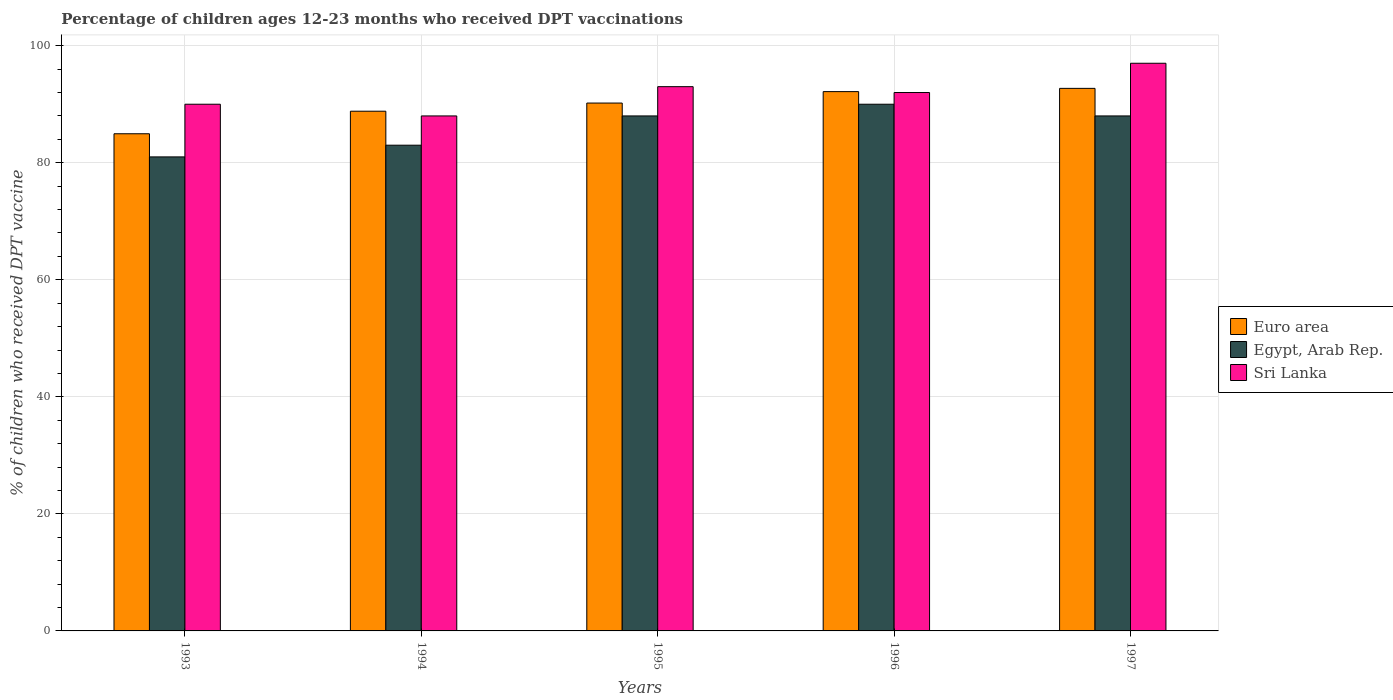Are the number of bars per tick equal to the number of legend labels?
Your answer should be very brief. Yes. How many bars are there on the 1st tick from the right?
Offer a very short reply. 3. In how many cases, is the number of bars for a given year not equal to the number of legend labels?
Offer a terse response. 0. What is the percentage of children who received DPT vaccination in Sri Lanka in 1995?
Keep it short and to the point. 93. Across all years, what is the maximum percentage of children who received DPT vaccination in Egypt, Arab Rep.?
Keep it short and to the point. 90. Across all years, what is the minimum percentage of children who received DPT vaccination in Sri Lanka?
Ensure brevity in your answer.  88. In which year was the percentage of children who received DPT vaccination in Euro area maximum?
Keep it short and to the point. 1997. What is the total percentage of children who received DPT vaccination in Euro area in the graph?
Give a very brief answer. 448.82. What is the difference between the percentage of children who received DPT vaccination in Sri Lanka in 1994 and that in 1996?
Keep it short and to the point. -4. What is the difference between the percentage of children who received DPT vaccination in Sri Lanka in 1996 and the percentage of children who received DPT vaccination in Euro area in 1994?
Ensure brevity in your answer.  3.19. What is the average percentage of children who received DPT vaccination in Egypt, Arab Rep. per year?
Give a very brief answer. 86. In the year 1993, what is the difference between the percentage of children who received DPT vaccination in Euro area and percentage of children who received DPT vaccination in Egypt, Arab Rep.?
Provide a short and direct response. 3.95. What is the ratio of the percentage of children who received DPT vaccination in Egypt, Arab Rep. in 1994 to that in 1997?
Your answer should be very brief. 0.94. What is the difference between the highest and the lowest percentage of children who received DPT vaccination in Sri Lanka?
Your response must be concise. 9. What does the 2nd bar from the left in 1993 represents?
Your answer should be compact. Egypt, Arab Rep. What does the 2nd bar from the right in 1993 represents?
Your response must be concise. Egypt, Arab Rep. Are all the bars in the graph horizontal?
Keep it short and to the point. No. Are the values on the major ticks of Y-axis written in scientific E-notation?
Provide a succinct answer. No. Does the graph contain any zero values?
Ensure brevity in your answer.  No. Does the graph contain grids?
Give a very brief answer. Yes. Where does the legend appear in the graph?
Provide a succinct answer. Center right. How are the legend labels stacked?
Offer a very short reply. Vertical. What is the title of the graph?
Keep it short and to the point. Percentage of children ages 12-23 months who received DPT vaccinations. What is the label or title of the Y-axis?
Offer a very short reply. % of children who received DPT vaccine. What is the % of children who received DPT vaccine in Euro area in 1993?
Your response must be concise. 84.95. What is the % of children who received DPT vaccine in Euro area in 1994?
Your answer should be compact. 88.81. What is the % of children who received DPT vaccine in Euro area in 1995?
Make the answer very short. 90.2. What is the % of children who received DPT vaccine in Egypt, Arab Rep. in 1995?
Give a very brief answer. 88. What is the % of children who received DPT vaccine of Sri Lanka in 1995?
Offer a terse response. 93. What is the % of children who received DPT vaccine in Euro area in 1996?
Your answer should be compact. 92.15. What is the % of children who received DPT vaccine of Sri Lanka in 1996?
Provide a short and direct response. 92. What is the % of children who received DPT vaccine of Euro area in 1997?
Offer a very short reply. 92.71. What is the % of children who received DPT vaccine in Sri Lanka in 1997?
Give a very brief answer. 97. Across all years, what is the maximum % of children who received DPT vaccine of Euro area?
Offer a terse response. 92.71. Across all years, what is the maximum % of children who received DPT vaccine in Egypt, Arab Rep.?
Your answer should be compact. 90. Across all years, what is the maximum % of children who received DPT vaccine of Sri Lanka?
Offer a very short reply. 97. Across all years, what is the minimum % of children who received DPT vaccine of Euro area?
Your response must be concise. 84.95. Across all years, what is the minimum % of children who received DPT vaccine of Egypt, Arab Rep.?
Offer a terse response. 81. Across all years, what is the minimum % of children who received DPT vaccine in Sri Lanka?
Provide a short and direct response. 88. What is the total % of children who received DPT vaccine of Euro area in the graph?
Your answer should be very brief. 448.82. What is the total % of children who received DPT vaccine in Egypt, Arab Rep. in the graph?
Keep it short and to the point. 430. What is the total % of children who received DPT vaccine in Sri Lanka in the graph?
Provide a succinct answer. 460. What is the difference between the % of children who received DPT vaccine of Euro area in 1993 and that in 1994?
Make the answer very short. -3.85. What is the difference between the % of children who received DPT vaccine of Euro area in 1993 and that in 1995?
Give a very brief answer. -5.25. What is the difference between the % of children who received DPT vaccine of Egypt, Arab Rep. in 1993 and that in 1995?
Provide a short and direct response. -7. What is the difference between the % of children who received DPT vaccine in Euro area in 1993 and that in 1996?
Ensure brevity in your answer.  -7.2. What is the difference between the % of children who received DPT vaccine of Egypt, Arab Rep. in 1993 and that in 1996?
Offer a very short reply. -9. What is the difference between the % of children who received DPT vaccine in Sri Lanka in 1993 and that in 1996?
Offer a very short reply. -2. What is the difference between the % of children who received DPT vaccine in Euro area in 1993 and that in 1997?
Give a very brief answer. -7.76. What is the difference between the % of children who received DPT vaccine in Egypt, Arab Rep. in 1993 and that in 1997?
Provide a succinct answer. -7. What is the difference between the % of children who received DPT vaccine in Sri Lanka in 1993 and that in 1997?
Provide a short and direct response. -7. What is the difference between the % of children who received DPT vaccine of Euro area in 1994 and that in 1995?
Offer a very short reply. -1.39. What is the difference between the % of children who received DPT vaccine in Egypt, Arab Rep. in 1994 and that in 1995?
Your response must be concise. -5. What is the difference between the % of children who received DPT vaccine of Euro area in 1994 and that in 1996?
Offer a very short reply. -3.35. What is the difference between the % of children who received DPT vaccine of Euro area in 1994 and that in 1997?
Offer a terse response. -3.9. What is the difference between the % of children who received DPT vaccine in Egypt, Arab Rep. in 1994 and that in 1997?
Ensure brevity in your answer.  -5. What is the difference between the % of children who received DPT vaccine in Euro area in 1995 and that in 1996?
Your answer should be compact. -1.95. What is the difference between the % of children who received DPT vaccine of Sri Lanka in 1995 and that in 1996?
Offer a very short reply. 1. What is the difference between the % of children who received DPT vaccine in Euro area in 1995 and that in 1997?
Provide a succinct answer. -2.51. What is the difference between the % of children who received DPT vaccine in Sri Lanka in 1995 and that in 1997?
Your answer should be very brief. -4. What is the difference between the % of children who received DPT vaccine of Euro area in 1996 and that in 1997?
Give a very brief answer. -0.56. What is the difference between the % of children who received DPT vaccine in Sri Lanka in 1996 and that in 1997?
Keep it short and to the point. -5. What is the difference between the % of children who received DPT vaccine in Euro area in 1993 and the % of children who received DPT vaccine in Egypt, Arab Rep. in 1994?
Keep it short and to the point. 1.95. What is the difference between the % of children who received DPT vaccine in Euro area in 1993 and the % of children who received DPT vaccine in Sri Lanka in 1994?
Make the answer very short. -3.05. What is the difference between the % of children who received DPT vaccine in Euro area in 1993 and the % of children who received DPT vaccine in Egypt, Arab Rep. in 1995?
Make the answer very short. -3.05. What is the difference between the % of children who received DPT vaccine in Euro area in 1993 and the % of children who received DPT vaccine in Sri Lanka in 1995?
Your answer should be compact. -8.05. What is the difference between the % of children who received DPT vaccine of Egypt, Arab Rep. in 1993 and the % of children who received DPT vaccine of Sri Lanka in 1995?
Offer a very short reply. -12. What is the difference between the % of children who received DPT vaccine in Euro area in 1993 and the % of children who received DPT vaccine in Egypt, Arab Rep. in 1996?
Offer a terse response. -5.05. What is the difference between the % of children who received DPT vaccine in Euro area in 1993 and the % of children who received DPT vaccine in Sri Lanka in 1996?
Keep it short and to the point. -7.05. What is the difference between the % of children who received DPT vaccine of Egypt, Arab Rep. in 1993 and the % of children who received DPT vaccine of Sri Lanka in 1996?
Provide a short and direct response. -11. What is the difference between the % of children who received DPT vaccine of Euro area in 1993 and the % of children who received DPT vaccine of Egypt, Arab Rep. in 1997?
Offer a very short reply. -3.05. What is the difference between the % of children who received DPT vaccine in Euro area in 1993 and the % of children who received DPT vaccine in Sri Lanka in 1997?
Provide a succinct answer. -12.05. What is the difference between the % of children who received DPT vaccine in Euro area in 1994 and the % of children who received DPT vaccine in Egypt, Arab Rep. in 1995?
Keep it short and to the point. 0.81. What is the difference between the % of children who received DPT vaccine of Euro area in 1994 and the % of children who received DPT vaccine of Sri Lanka in 1995?
Provide a succinct answer. -4.19. What is the difference between the % of children who received DPT vaccine of Euro area in 1994 and the % of children who received DPT vaccine of Egypt, Arab Rep. in 1996?
Your answer should be very brief. -1.19. What is the difference between the % of children who received DPT vaccine in Euro area in 1994 and the % of children who received DPT vaccine in Sri Lanka in 1996?
Keep it short and to the point. -3.19. What is the difference between the % of children who received DPT vaccine in Egypt, Arab Rep. in 1994 and the % of children who received DPT vaccine in Sri Lanka in 1996?
Offer a terse response. -9. What is the difference between the % of children who received DPT vaccine in Euro area in 1994 and the % of children who received DPT vaccine in Egypt, Arab Rep. in 1997?
Ensure brevity in your answer.  0.81. What is the difference between the % of children who received DPT vaccine in Euro area in 1994 and the % of children who received DPT vaccine in Sri Lanka in 1997?
Keep it short and to the point. -8.19. What is the difference between the % of children who received DPT vaccine of Euro area in 1995 and the % of children who received DPT vaccine of Egypt, Arab Rep. in 1996?
Offer a terse response. 0.2. What is the difference between the % of children who received DPT vaccine of Euro area in 1995 and the % of children who received DPT vaccine of Sri Lanka in 1996?
Your answer should be very brief. -1.8. What is the difference between the % of children who received DPT vaccine of Egypt, Arab Rep. in 1995 and the % of children who received DPT vaccine of Sri Lanka in 1996?
Provide a succinct answer. -4. What is the difference between the % of children who received DPT vaccine in Euro area in 1995 and the % of children who received DPT vaccine in Egypt, Arab Rep. in 1997?
Ensure brevity in your answer.  2.2. What is the difference between the % of children who received DPT vaccine in Euro area in 1995 and the % of children who received DPT vaccine in Sri Lanka in 1997?
Offer a very short reply. -6.8. What is the difference between the % of children who received DPT vaccine in Euro area in 1996 and the % of children who received DPT vaccine in Egypt, Arab Rep. in 1997?
Offer a very short reply. 4.15. What is the difference between the % of children who received DPT vaccine in Euro area in 1996 and the % of children who received DPT vaccine in Sri Lanka in 1997?
Your response must be concise. -4.85. What is the average % of children who received DPT vaccine in Euro area per year?
Ensure brevity in your answer.  89.76. What is the average % of children who received DPT vaccine of Sri Lanka per year?
Give a very brief answer. 92. In the year 1993, what is the difference between the % of children who received DPT vaccine of Euro area and % of children who received DPT vaccine of Egypt, Arab Rep.?
Make the answer very short. 3.95. In the year 1993, what is the difference between the % of children who received DPT vaccine in Euro area and % of children who received DPT vaccine in Sri Lanka?
Keep it short and to the point. -5.05. In the year 1994, what is the difference between the % of children who received DPT vaccine in Euro area and % of children who received DPT vaccine in Egypt, Arab Rep.?
Keep it short and to the point. 5.81. In the year 1994, what is the difference between the % of children who received DPT vaccine of Euro area and % of children who received DPT vaccine of Sri Lanka?
Provide a succinct answer. 0.81. In the year 1995, what is the difference between the % of children who received DPT vaccine of Euro area and % of children who received DPT vaccine of Egypt, Arab Rep.?
Give a very brief answer. 2.2. In the year 1995, what is the difference between the % of children who received DPT vaccine of Euro area and % of children who received DPT vaccine of Sri Lanka?
Provide a short and direct response. -2.8. In the year 1995, what is the difference between the % of children who received DPT vaccine in Egypt, Arab Rep. and % of children who received DPT vaccine in Sri Lanka?
Provide a succinct answer. -5. In the year 1996, what is the difference between the % of children who received DPT vaccine in Euro area and % of children who received DPT vaccine in Egypt, Arab Rep.?
Provide a short and direct response. 2.15. In the year 1996, what is the difference between the % of children who received DPT vaccine in Euro area and % of children who received DPT vaccine in Sri Lanka?
Provide a succinct answer. 0.15. In the year 1997, what is the difference between the % of children who received DPT vaccine of Euro area and % of children who received DPT vaccine of Egypt, Arab Rep.?
Your answer should be very brief. 4.71. In the year 1997, what is the difference between the % of children who received DPT vaccine of Euro area and % of children who received DPT vaccine of Sri Lanka?
Provide a short and direct response. -4.29. What is the ratio of the % of children who received DPT vaccine in Euro area in 1993 to that in 1994?
Your answer should be compact. 0.96. What is the ratio of the % of children who received DPT vaccine in Egypt, Arab Rep. in 1993 to that in 1994?
Ensure brevity in your answer.  0.98. What is the ratio of the % of children who received DPT vaccine in Sri Lanka in 1993 to that in 1994?
Your response must be concise. 1.02. What is the ratio of the % of children who received DPT vaccine of Euro area in 1993 to that in 1995?
Ensure brevity in your answer.  0.94. What is the ratio of the % of children who received DPT vaccine of Egypt, Arab Rep. in 1993 to that in 1995?
Ensure brevity in your answer.  0.92. What is the ratio of the % of children who received DPT vaccine of Euro area in 1993 to that in 1996?
Your answer should be very brief. 0.92. What is the ratio of the % of children who received DPT vaccine in Egypt, Arab Rep. in 1993 to that in 1996?
Give a very brief answer. 0.9. What is the ratio of the % of children who received DPT vaccine in Sri Lanka in 1993 to that in 1996?
Make the answer very short. 0.98. What is the ratio of the % of children who received DPT vaccine of Euro area in 1993 to that in 1997?
Make the answer very short. 0.92. What is the ratio of the % of children who received DPT vaccine in Egypt, Arab Rep. in 1993 to that in 1997?
Ensure brevity in your answer.  0.92. What is the ratio of the % of children who received DPT vaccine in Sri Lanka in 1993 to that in 1997?
Keep it short and to the point. 0.93. What is the ratio of the % of children who received DPT vaccine in Euro area in 1994 to that in 1995?
Your response must be concise. 0.98. What is the ratio of the % of children who received DPT vaccine of Egypt, Arab Rep. in 1994 to that in 1995?
Your answer should be compact. 0.94. What is the ratio of the % of children who received DPT vaccine of Sri Lanka in 1994 to that in 1995?
Provide a succinct answer. 0.95. What is the ratio of the % of children who received DPT vaccine of Euro area in 1994 to that in 1996?
Make the answer very short. 0.96. What is the ratio of the % of children who received DPT vaccine in Egypt, Arab Rep. in 1994 to that in 1996?
Make the answer very short. 0.92. What is the ratio of the % of children who received DPT vaccine of Sri Lanka in 1994 to that in 1996?
Make the answer very short. 0.96. What is the ratio of the % of children who received DPT vaccine in Euro area in 1994 to that in 1997?
Keep it short and to the point. 0.96. What is the ratio of the % of children who received DPT vaccine of Egypt, Arab Rep. in 1994 to that in 1997?
Make the answer very short. 0.94. What is the ratio of the % of children who received DPT vaccine of Sri Lanka in 1994 to that in 1997?
Provide a short and direct response. 0.91. What is the ratio of the % of children who received DPT vaccine in Euro area in 1995 to that in 1996?
Offer a very short reply. 0.98. What is the ratio of the % of children who received DPT vaccine in Egypt, Arab Rep. in 1995 to that in 1996?
Offer a terse response. 0.98. What is the ratio of the % of children who received DPT vaccine in Sri Lanka in 1995 to that in 1996?
Keep it short and to the point. 1.01. What is the ratio of the % of children who received DPT vaccine of Euro area in 1995 to that in 1997?
Your answer should be compact. 0.97. What is the ratio of the % of children who received DPT vaccine of Egypt, Arab Rep. in 1995 to that in 1997?
Provide a succinct answer. 1. What is the ratio of the % of children who received DPT vaccine of Sri Lanka in 1995 to that in 1997?
Provide a short and direct response. 0.96. What is the ratio of the % of children who received DPT vaccine of Euro area in 1996 to that in 1997?
Provide a succinct answer. 0.99. What is the ratio of the % of children who received DPT vaccine in Egypt, Arab Rep. in 1996 to that in 1997?
Offer a very short reply. 1.02. What is the ratio of the % of children who received DPT vaccine of Sri Lanka in 1996 to that in 1997?
Ensure brevity in your answer.  0.95. What is the difference between the highest and the second highest % of children who received DPT vaccine in Euro area?
Your response must be concise. 0.56. What is the difference between the highest and the lowest % of children who received DPT vaccine of Euro area?
Keep it short and to the point. 7.76. What is the difference between the highest and the lowest % of children who received DPT vaccine in Egypt, Arab Rep.?
Your answer should be very brief. 9. What is the difference between the highest and the lowest % of children who received DPT vaccine in Sri Lanka?
Ensure brevity in your answer.  9. 